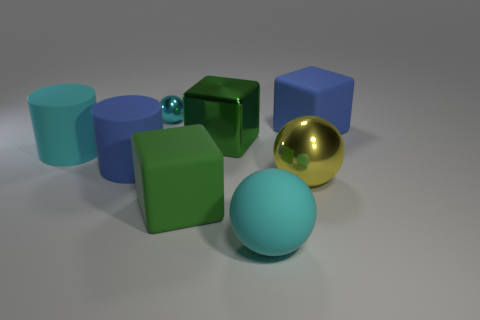Subtract all small cyan spheres. How many spheres are left? 2 Add 2 green rubber spheres. How many objects exist? 10 Subtract all cyan cylinders. How many cylinders are left? 1 Subtract all cylinders. How many objects are left? 6 Subtract 1 cubes. How many cubes are left? 2 Subtract all green cubes. Subtract all green balls. How many cubes are left? 1 Subtract all blue cylinders. How many green balls are left? 0 Subtract all small cyan metal balls. Subtract all big metal things. How many objects are left? 5 Add 1 large shiny spheres. How many large shiny spheres are left? 2 Add 7 big cyan cylinders. How many big cyan cylinders exist? 8 